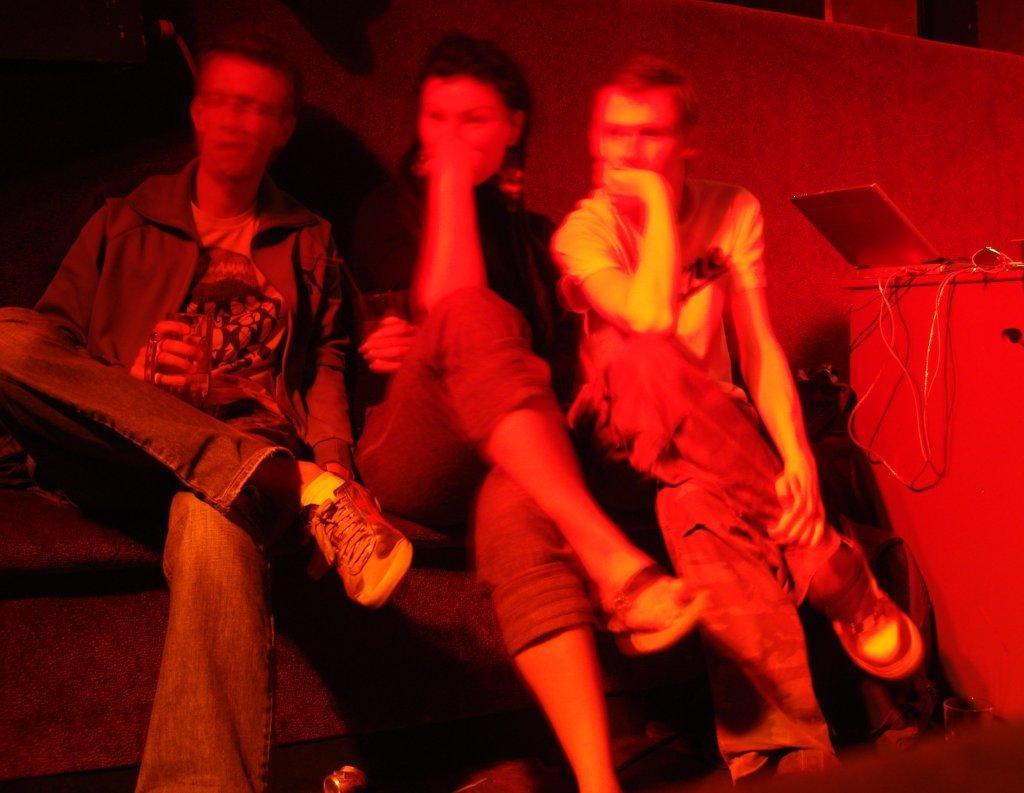Describe this image in one or two sentences. In this picture I can see three people sitting. I can see the laptop on the right side on the table. 